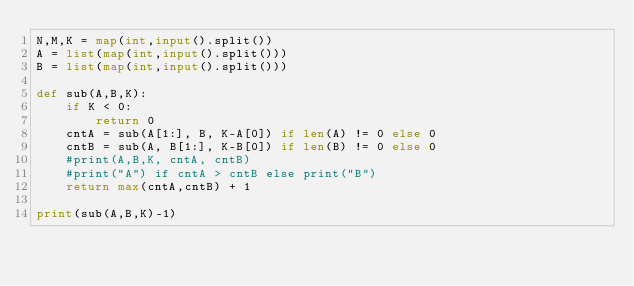Convert code to text. <code><loc_0><loc_0><loc_500><loc_500><_Python_>N,M,K = map(int,input().split())
A = list(map(int,input().split()))
B = list(map(int,input().split()))

def sub(A,B,K):
    if K < 0:
        return 0
    cntA = sub(A[1:], B, K-A[0]) if len(A) != 0 else 0
    cntB = sub(A, B[1:], K-B[0]) if len(B) != 0 else 0
    #print(A,B,K, cntA, cntB)
    #print("A") if cntA > cntB else print("B")
    return max(cntA,cntB) + 1

print(sub(A,B,K)-1)</code> 